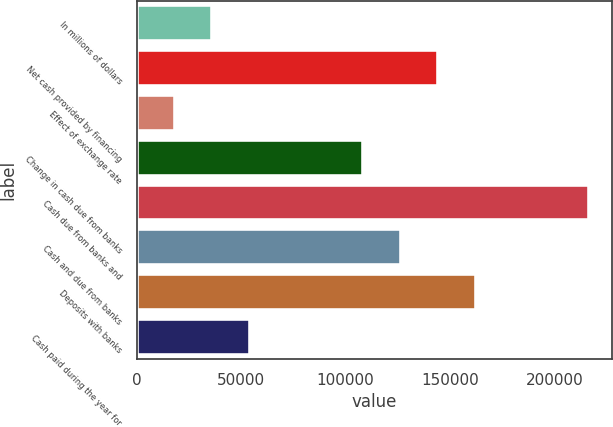Convert chart to OTSL. <chart><loc_0><loc_0><loc_500><loc_500><bar_chart><fcel>In millions of dollars<fcel>Net cash provided by financing<fcel>Effect of exchange rate<fcel>Change in cash due from banks<fcel>Cash due from banks and<fcel>Cash and due from banks<fcel>Deposits with banks<fcel>Cash paid during the year for<nl><fcel>36193.6<fcel>144435<fcel>18153.3<fcel>108355<fcel>216597<fcel>126395<fcel>162476<fcel>54233.9<nl></chart> 